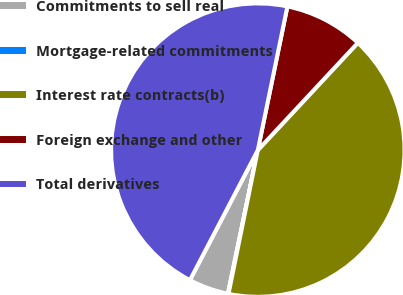Convert chart to OTSL. <chart><loc_0><loc_0><loc_500><loc_500><pie_chart><fcel>Commitments to sell real<fcel>Mortgage-related commitments<fcel>Interest rate contracts(b)<fcel>Foreign exchange and other<fcel>Total derivatives<nl><fcel>4.39%<fcel>0.07%<fcel>41.26%<fcel>8.71%<fcel>45.57%<nl></chart> 